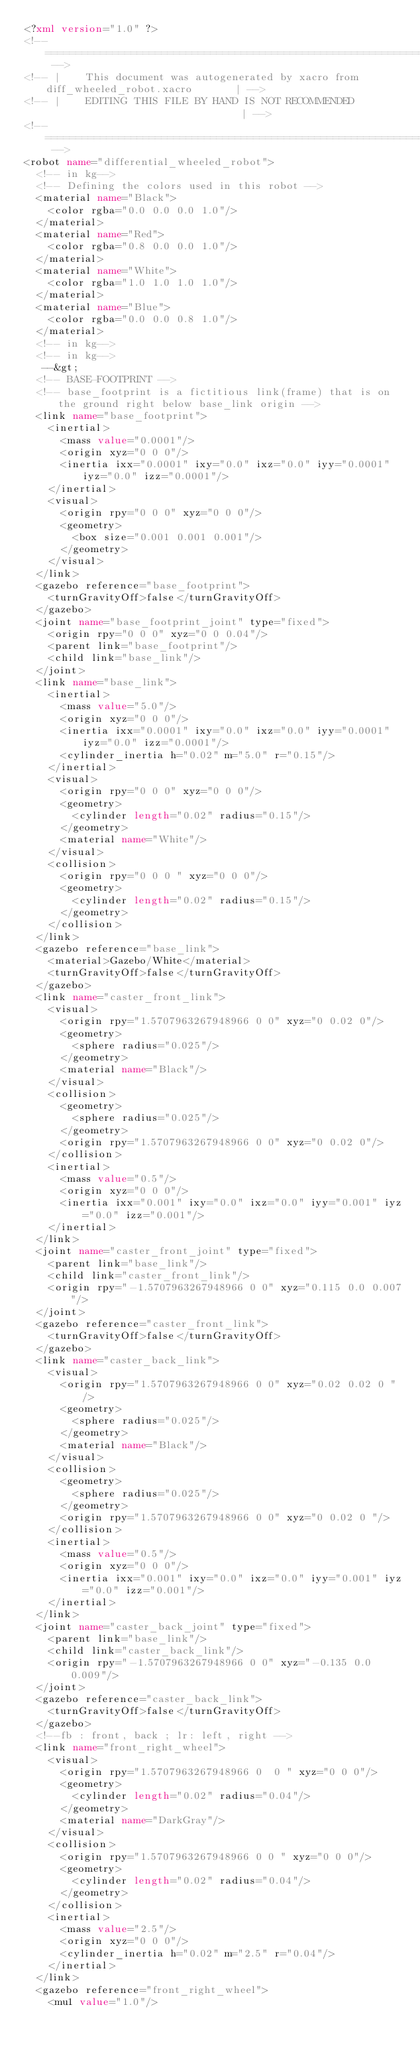Convert code to text. <code><loc_0><loc_0><loc_500><loc_500><_XML_><?xml version="1.0" ?>
<!-- =================================================================================== -->
<!-- |    This document was autogenerated by xacro from diff_wheeled_robot.xacro       | -->
<!-- |    EDITING THIS FILE BY HAND IS NOT RECOMMENDED                                 | -->
<!-- =================================================================================== -->
<robot name="differential_wheeled_robot">
  <!-- in kg-->
  <!-- Defining the colors used in this robot -->
  <material name="Black">
    <color rgba="0.0 0.0 0.0 1.0"/>
  </material>
  <material name="Red">
    <color rgba="0.8 0.0 0.0 1.0"/>
  </material>
  <material name="White">
    <color rgba="1.0 1.0 1.0 1.0"/>
  </material>
  <material name="Blue">
    <color rgba="0.0 0.0 0.8 1.0"/>
  </material>
  <!-- in kg-->
  <!-- in kg-->
   --&gt; 
  <!-- BASE-FOOTPRINT -->
  <!-- base_footprint is a fictitious link(frame) that is on the ground right below base_link origin -->
  <link name="base_footprint">
    <inertial>
      <mass value="0.0001"/>
      <origin xyz="0 0 0"/>
      <inertia ixx="0.0001" ixy="0.0" ixz="0.0" iyy="0.0001" iyz="0.0" izz="0.0001"/>
    </inertial>
    <visual>
      <origin rpy="0 0 0" xyz="0 0 0"/>
      <geometry>
        <box size="0.001 0.001 0.001"/>
      </geometry>
    </visual>
  </link>
  <gazebo reference="base_footprint">
    <turnGravityOff>false</turnGravityOff>
  </gazebo>
  <joint name="base_footprint_joint" type="fixed">
    <origin rpy="0 0 0" xyz="0 0 0.04"/>
    <parent link="base_footprint"/>
    <child link="base_link"/>
  </joint>
  <link name="base_link">
    <inertial>
      <mass value="5.0"/>
      <origin xyz="0 0 0"/>
      <inertia ixx="0.0001" ixy="0.0" ixz="0.0" iyy="0.0001" iyz="0.0" izz="0.0001"/>
      <cylinder_inertia h="0.02" m="5.0" r="0.15"/>
    </inertial>
    <visual>
      <origin rpy="0 0 0" xyz="0 0 0"/>
      <geometry>
        <cylinder length="0.02" radius="0.15"/>
      </geometry>
      <material name="White"/>
    </visual>
    <collision>
      <origin rpy="0 0 0 " xyz="0 0 0"/>
      <geometry>
        <cylinder length="0.02" radius="0.15"/>
      </geometry>
    </collision>
  </link>
  <gazebo reference="base_link">
    <material>Gazebo/White</material>
    <turnGravityOff>false</turnGravityOff>
  </gazebo>
  <link name="caster_front_link">
    <visual>
      <origin rpy="1.5707963267948966 0 0" xyz="0 0.02 0"/>
      <geometry>
        <sphere radius="0.025"/>
      </geometry>
      <material name="Black"/>
    </visual>
    <collision>
      <geometry>
        <sphere radius="0.025"/>
      </geometry>
      <origin rpy="1.5707963267948966 0 0" xyz="0 0.02 0"/>
    </collision>
    <inertial>
      <mass value="0.5"/>
      <origin xyz="0 0 0"/>
      <inertia ixx="0.001" ixy="0.0" ixz="0.0" iyy="0.001" iyz="0.0" izz="0.001"/>
    </inertial>
  </link>
  <joint name="caster_front_joint" type="fixed">
    <parent link="base_link"/>
    <child link="caster_front_link"/>
    <origin rpy="-1.5707963267948966 0 0" xyz="0.115 0.0 0.007"/>
  </joint>
  <gazebo reference="caster_front_link">
    <turnGravityOff>false</turnGravityOff>
  </gazebo>
  <link name="caster_back_link">
    <visual>
      <origin rpy="1.5707963267948966 0 0" xyz="0.02 0.02 0 "/>
      <geometry>
        <sphere radius="0.025"/>
      </geometry>
      <material name="Black"/>
    </visual>
    <collision>
      <geometry>
        <sphere radius="0.025"/>
      </geometry>
      <origin rpy="1.5707963267948966 0 0" xyz="0 0.02 0 "/>
    </collision>
    <inertial>
      <mass value="0.5"/>
      <origin xyz="0 0 0"/>
      <inertia ixx="0.001" ixy="0.0" ixz="0.0" iyy="0.001" iyz="0.0" izz="0.001"/>
    </inertial>
  </link>
  <joint name="caster_back_joint" type="fixed">
    <parent link="base_link"/>
    <child link="caster_back_link"/>
    <origin rpy="-1.5707963267948966 0 0" xyz="-0.135 0.0 0.009"/>
  </joint>
  <gazebo reference="caster_back_link">
    <turnGravityOff>false</turnGravityOff>
  </gazebo>
  <!--fb : front, back ; lr: left, right -->
  <link name="front_right_wheel">
    <visual>
      <origin rpy="1.5707963267948966 0  0 " xyz="0 0 0"/>
      <geometry>
        <cylinder length="0.02" radius="0.04"/>
      </geometry>
      <material name="DarkGray"/>
    </visual>
    <collision>
      <origin rpy="1.5707963267948966 0 0 " xyz="0 0 0"/>
      <geometry>
        <cylinder length="0.02" radius="0.04"/>
      </geometry>
    </collision>
    <inertial>
      <mass value="2.5"/>
      <origin xyz="0 0 0"/>
      <cylinder_inertia h="0.02" m="2.5" r="0.04"/>
    </inertial>
  </link>
  <gazebo reference="front_right_wheel">
    <mu1 value="1.0"/></code> 